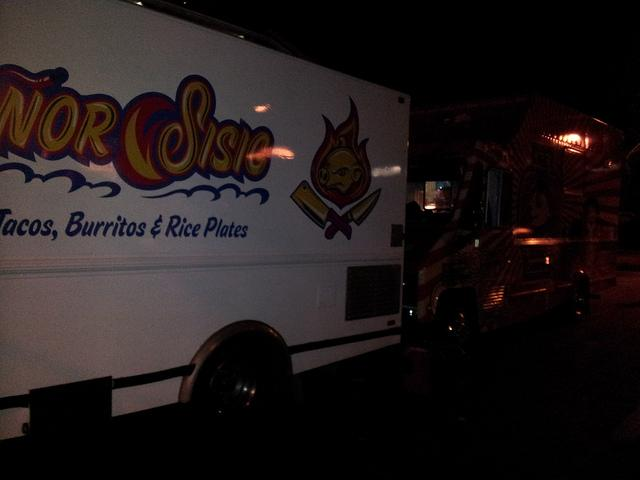What does the white truck do? Please explain your reasoning. sells food. You can tell because the side of the vehicle says burritos and rice plates. 